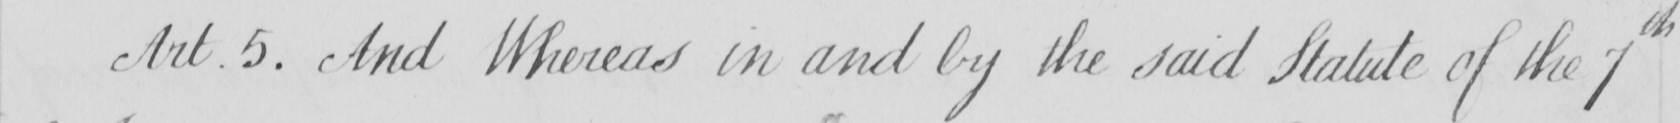Please provide the text content of this handwritten line. Art . 5 . And Whereas in and by the said Statute of the 7th 